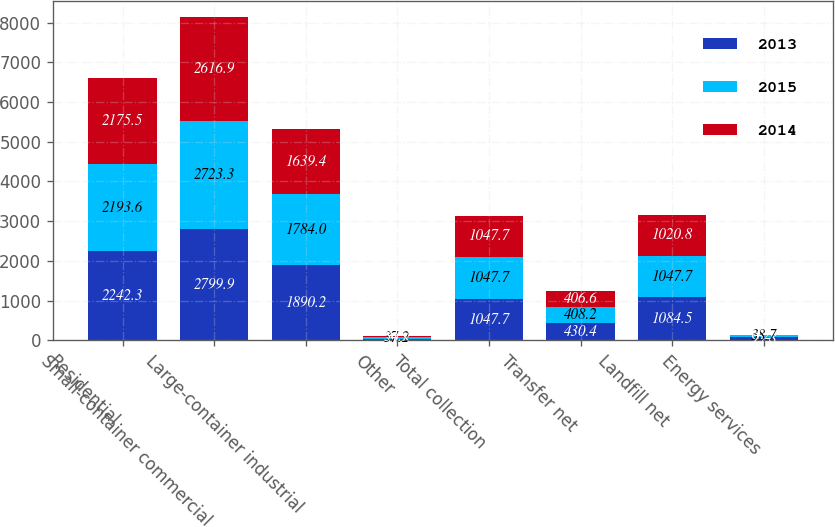Convert chart to OTSL. <chart><loc_0><loc_0><loc_500><loc_500><stacked_bar_chart><ecel><fcel>Residential<fcel>Small-container commercial<fcel>Large-container industrial<fcel>Other<fcel>Total collection<fcel>Transfer net<fcel>Landfill net<fcel>Energy services<nl><fcel>2013<fcel>2242.3<fcel>2799.9<fcel>1890.2<fcel>39.8<fcel>1047.7<fcel>430.4<fcel>1084.5<fcel>95.8<nl><fcel>2015<fcel>2193.6<fcel>2723.3<fcel>1784<fcel>37.2<fcel>1047.7<fcel>408.2<fcel>1047.7<fcel>38.7<nl><fcel>2014<fcel>2175.5<fcel>2616.9<fcel>1639.4<fcel>34.7<fcel>1047.7<fcel>406.6<fcel>1020.8<fcel>4.2<nl></chart> 